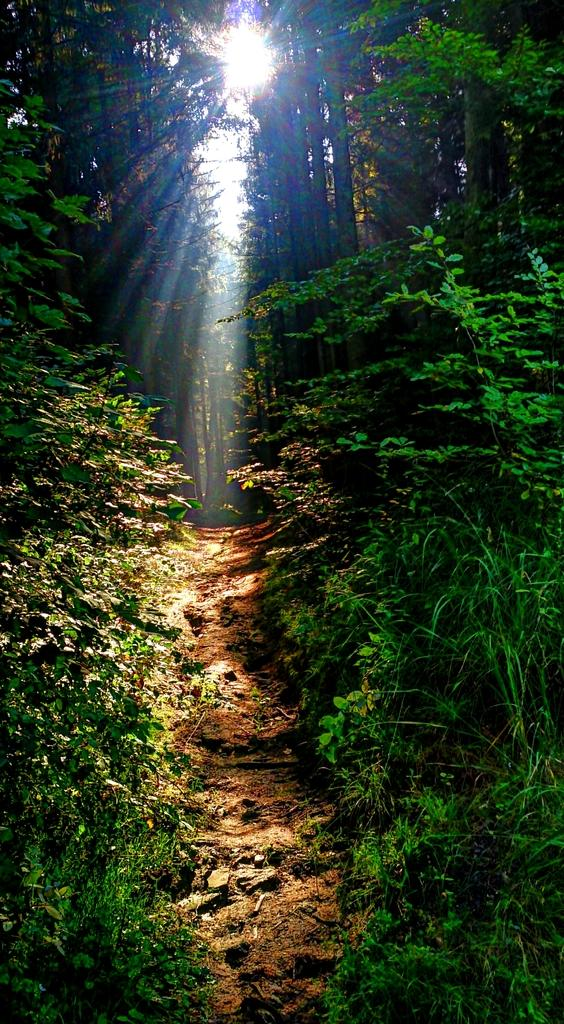What type of vegetation can be seen in the image? There are plants and trees in the image. Can you describe the specific types of plants or trees? The provided facts do not specify the types of plants or trees, so we cannot provide a detailed description. Where are the toys scattered on the street in the image? There are no toys or streets present in the image; it only features plants and trees. 